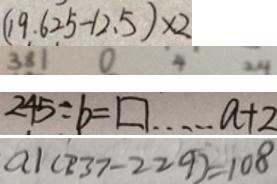<formula> <loc_0><loc_0><loc_500><loc_500>( 1 9 . 6 2 5 - 1 2 . 5 ) \times 2 
 3 8 1 0 4 2 4 
 2 4 5 \div b = \square \cdots a + 2 
 a 1 ( 2 3 7 - 2 2 9 ) = 1 0 8</formula> 